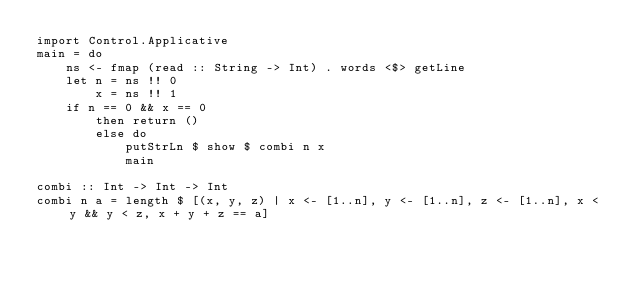Convert code to text. <code><loc_0><loc_0><loc_500><loc_500><_Haskell_>import Control.Applicative
main = do
    ns <- fmap (read :: String -> Int) . words <$> getLine
    let n = ns !! 0
        x = ns !! 1
    if n == 0 && x == 0
        then return ()
        else do
            putStrLn $ show $ combi n x
            main

combi :: Int -> Int -> Int
combi n a = length $ [(x, y, z) | x <- [1..n], y <- [1..n], z <- [1..n], x < y && y < z, x + y + z == a]</code> 